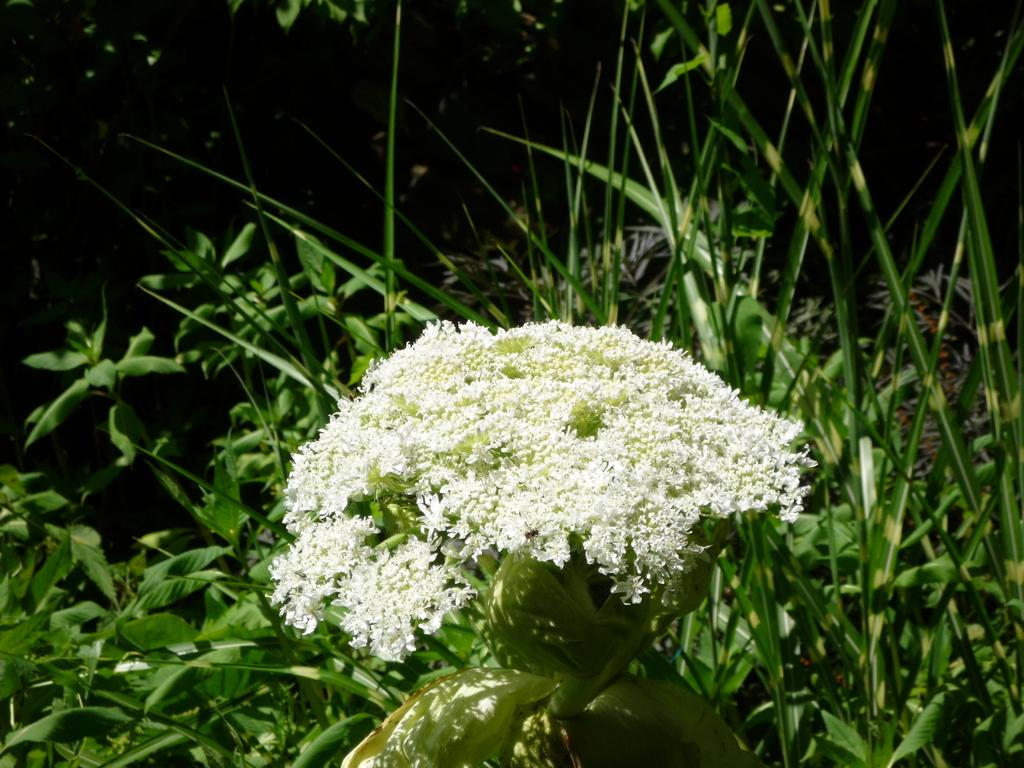What type of living organisms can be seen in the image? Flowers and plants are visible in the image. Can you describe the background of the image? The background of the image is dark. How many seas can be seen in the image? There are no seas present in the image; it features flowers and plants. What type of mark is visible on the plants in the image? There is no mark visible on the plants in the image; only flowers and plants are present. 